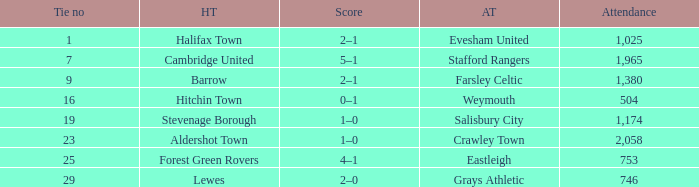Who was the away team in a tie no larger than 16 with forest green rovers at home? Eastleigh. 